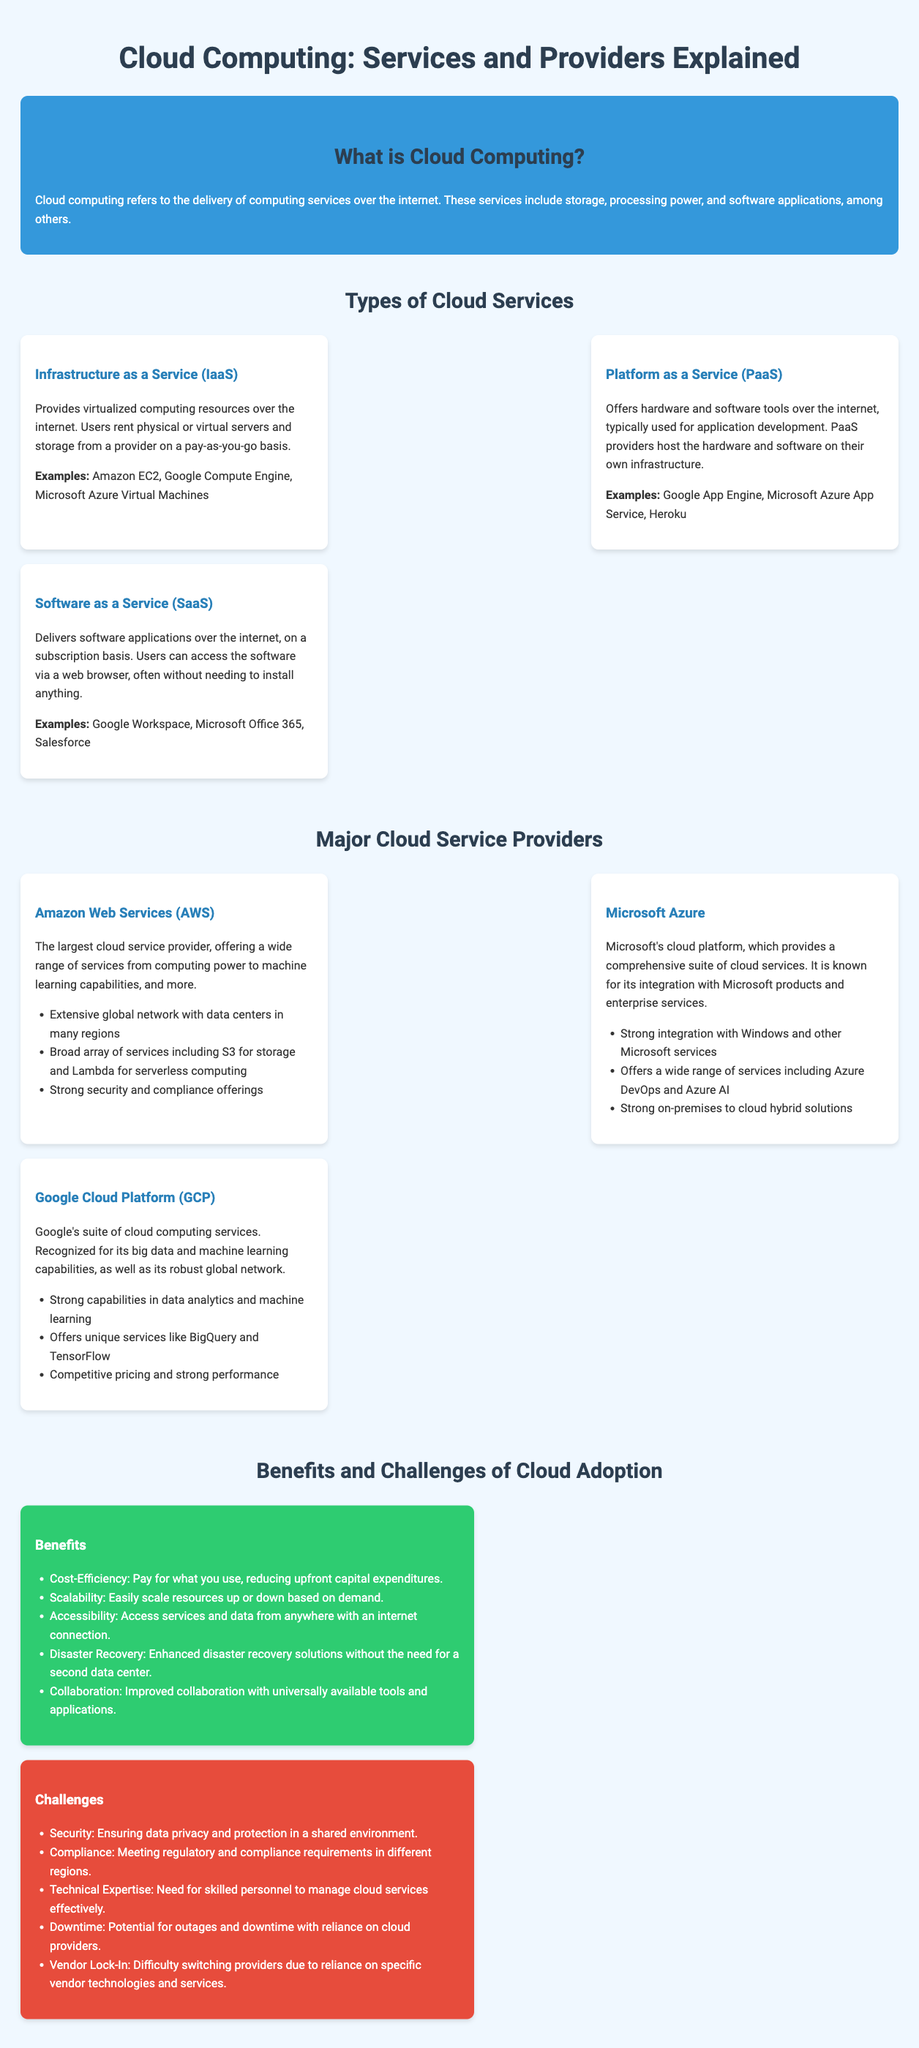what does IaaS stand for? IaaS is the abbreviation used in the document that stands for Infrastructure as a Service.
Answer: Infrastructure as a Service name three examples of SaaS applications mentioned in the document. The document lists Google Workspace, Microsoft Office 365, and Salesforce as examples of SaaS applications.
Answer: Google Workspace, Microsoft Office 365, Salesforce which cloud service provider is the largest? The document states that Amazon Web Services (AWS) is the largest cloud service provider.
Answer: Amazon Web Services (AWS) what is a key benefit of cloud adoption related to cost? According to the document, one of the benefits of cloud adoption is cost-efficiency, which involves paying for what you use.
Answer: Cost-Efficiency list one challenge of cloud adoption. The document identifies security as a challenge of cloud adoption, highlighting the need for data privacy and protection.
Answer: Security which cloud service offers application development tools? The document explains that Platform as a Service (PaaS) offers hardware and software tools for application development.
Answer: Platform as a Service (PaaS) how many major cloud providers are listed? The document includes three major cloud service providers: AWS, Microsoft Azure, and Google Cloud Platform.
Answer: Three what type of service does Google App Engine provide? The document classifies Google App Engine under Platform as a Service (PaaS) for application development.
Answer: Platform as a Service (PaaS) 